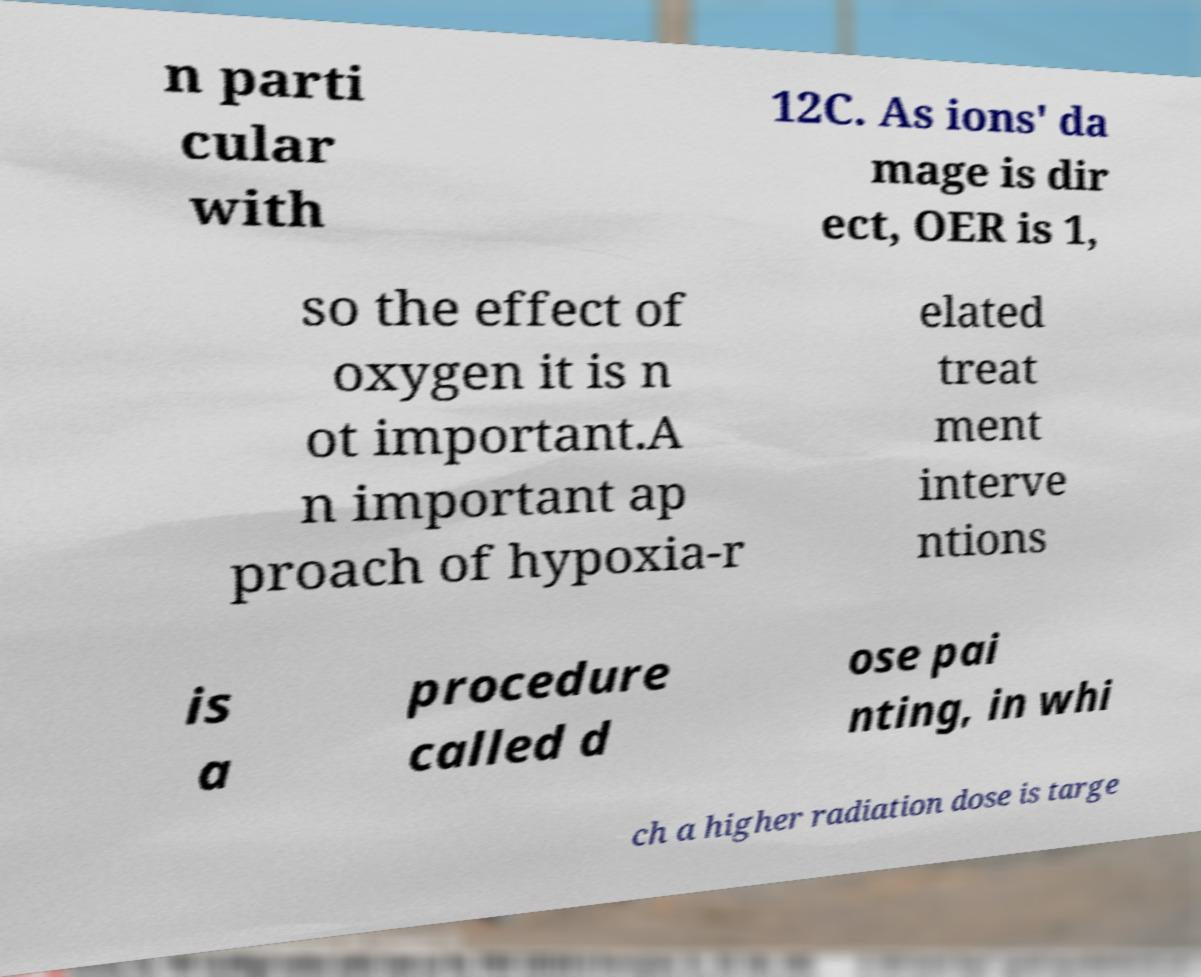Please read and relay the text visible in this image. What does it say? n parti cular with 12C. As ions' da mage is dir ect, OER is 1, so the effect of oxygen it is n ot important.A n important ap proach of hypoxia-r elated treat ment interve ntions is a procedure called d ose pai nting, in whi ch a higher radiation dose is targe 